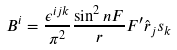Convert formula to latex. <formula><loc_0><loc_0><loc_500><loc_500>B ^ { i } = \frac { \epsilon ^ { i j k } } { \pi ^ { 2 } } \frac { \sin ^ { 2 } n F } { r } F ^ { \prime } \hat { r } _ { j } s _ { k }</formula> 